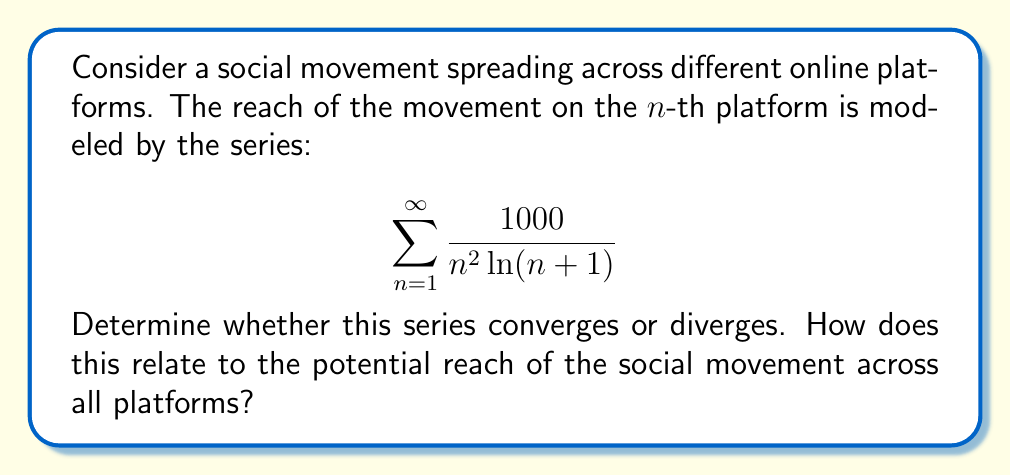Can you answer this question? To determine the convergence of this series, we can use the integral test:

1) First, let's define the function $f(x)$ that corresponds to the general term of our series:

   $$f(x) = \frac{1000}{x^2 \ln(x+1)}$$

2) Now, we need to check if $f(x)$ is continuous, positive, and decreasing for $x \geq 1$:
   - It's continuous for $x \geq 1$
   - It's positive for $x \geq 1$
   - To check if it's decreasing, we can take the derivative:
     $$f'(x) = -\frac{1000(2\ln(x+1) + \frac{x+1}{x})}{x^3(\ln(x+1))^2}$$
     This is negative for $x \geq 1$, so $f(x)$ is decreasing.

3) Now we can apply the integral test. The series converges if and only if the following improper integral converges:

   $$\int_{1}^{\infty} \frac{1000}{x^2 \ln(x+1)} dx$$

4) To evaluate this integral, we can use the substitution $u = \ln(x+1)$:
   
   $x = e^u - 1$
   $dx = e^u du$

5) Substituting:

   $$\int_{1}^{\infty} \frac{1000}{x^2 \ln(x+1)} dx = 1000\int_{\ln 2}^{\infty} \frac{e^u}{(e^u-1)^2 u} du$$

6) We can compare this to the integral of $\frac{1}{u^2}$:

   $$\frac{e^u}{(e^u-1)^2 u} < \frac{1}{u^2}$$ for large $u$

7) Since $\int_{\ln 2}^{\infty} \frac{1}{u^2} du$ converges, our original integral must also converge.

Therefore, by the integral test, the series converges.

In terms of the social movement, this suggests that while the movement may spread across many platforms, its total reach across all platforms is finite.
Answer: The series converges. 